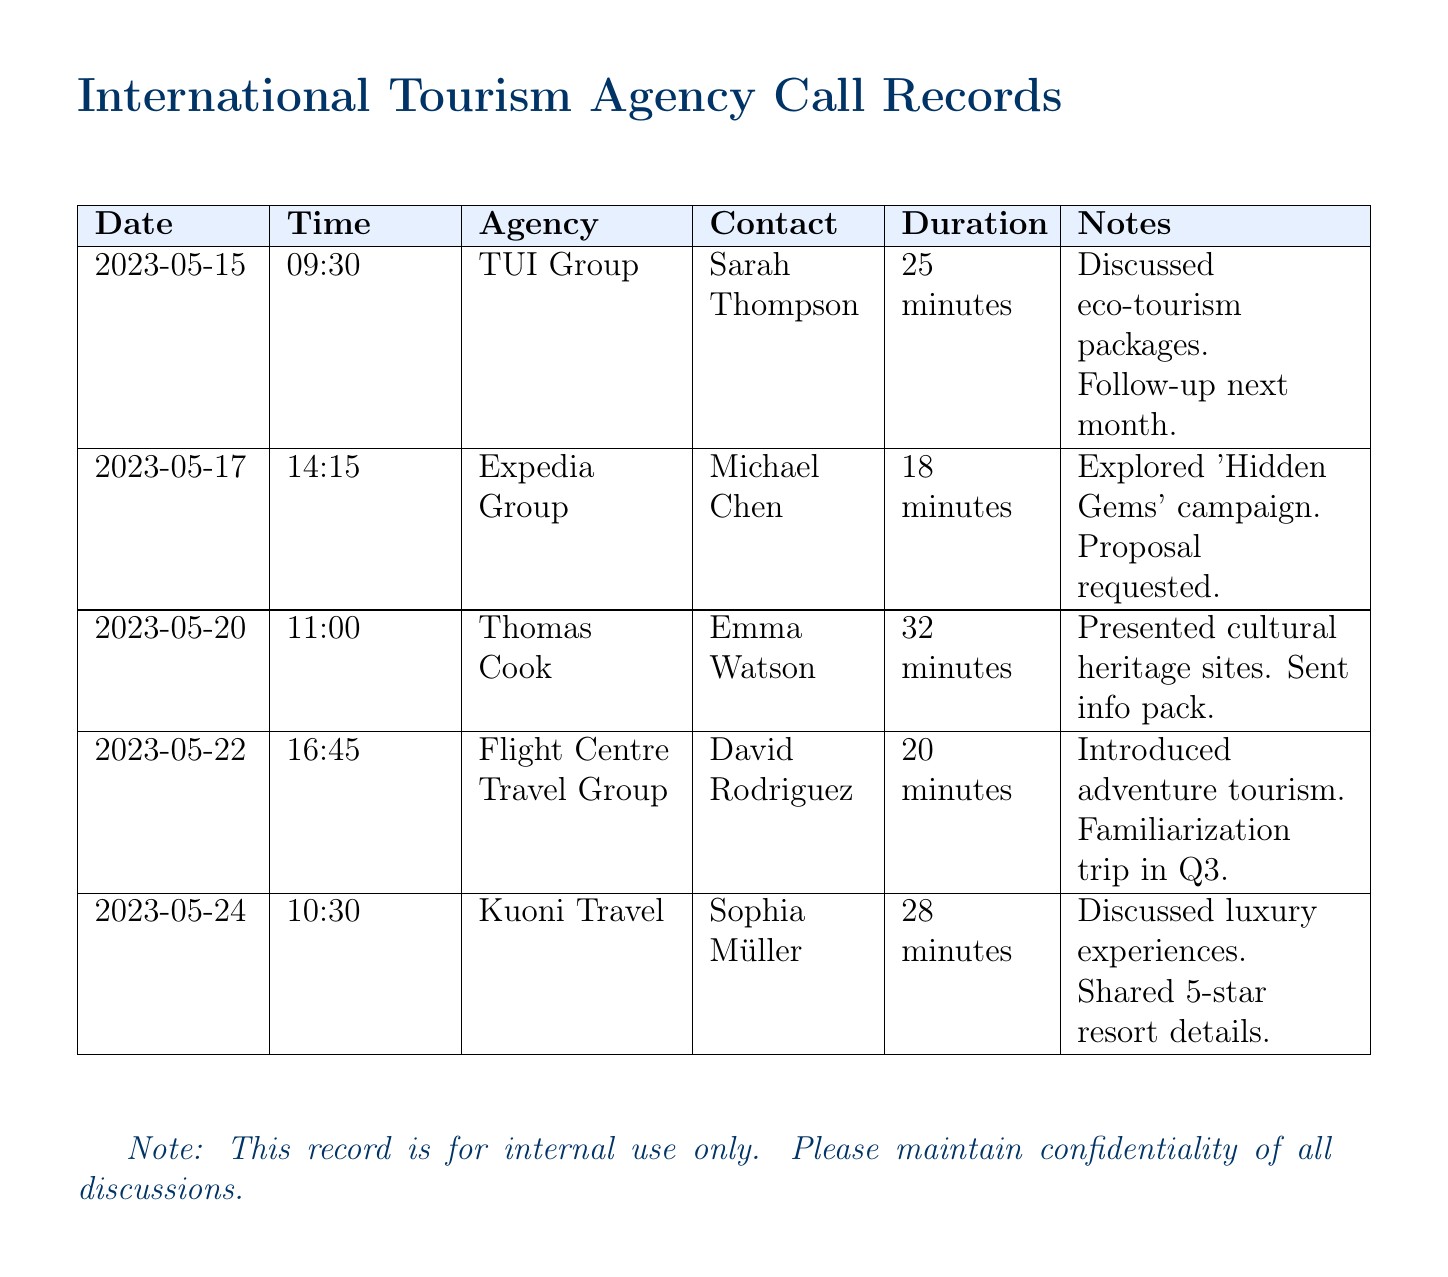What is the date of the call with TUI Group? The date of the call with TUI Group is specified in the document, which shows the date as 2023-05-15.
Answer: 2023-05-15 Who was the contact person for the call with Expedia Group? The document lists the contact person for Expedia Group as Michael Chen.
Answer: Michael Chen What was the duration of the call with Thomas Cook? The duration of the call with Thomas Cook is noted in the document as 32 minutes.
Answer: 32 minutes What tourism package was discussed with Flight Centre Travel Group? The discussion with Flight Centre Travel Group included adventure tourism packages, as mentioned in the notes.
Answer: Adventure tourism How many agencies were contacted in total? The total number of agencies listed in the document is counted from the entries, which equals five agencies.
Answer: Five What was requested from Expedia Group during the call? The document indicates that a proposal was requested from Expedia Group during the conversation.
Answer: Proposal Which agency did the call on 2023-05-24 pertain to? The call on 2023-05-24 is noted to be with Kuoni Travel, according to the records.
Answer: Kuoni Travel What information was sent after the call with Thomas Cook? The notes indicate that an information pack was sent after the call with Thomas Cook.
Answer: Info pack In which quarter is the familiarization trip planned with Flight Centre Travel Group? The document specifies that the familiarization trip is planned for Q3.
Answer: Q3 